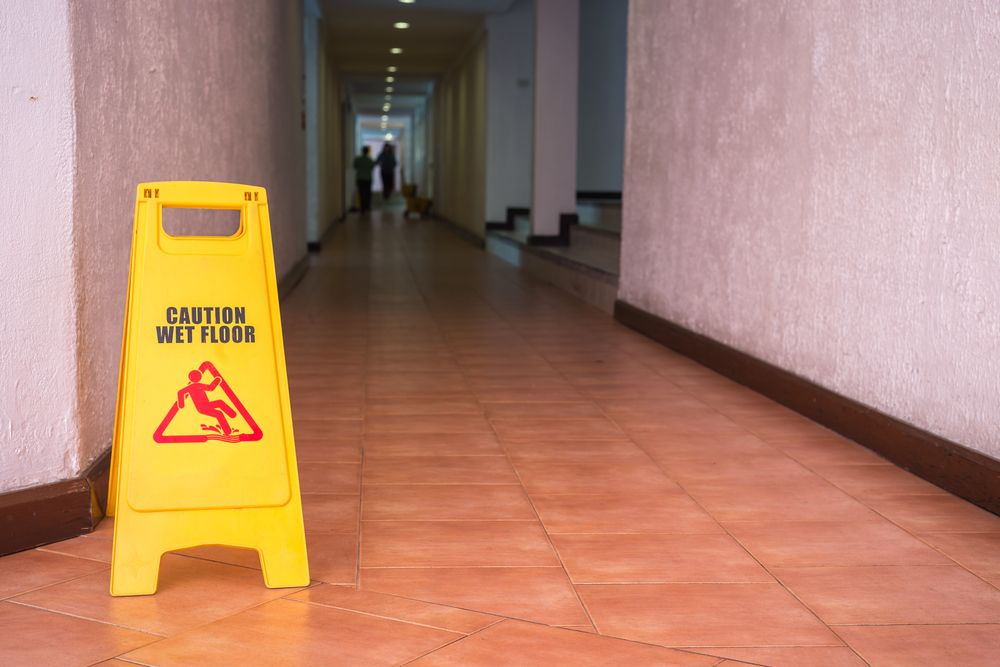What does the presence of a 'Caution Wet Floor' sign suggest about the building's policy on safety? The presence of a 'Caution Wet Floor' sign suggests that the building has a clear and proactive policy on safety. It indicates that the building management is attentive to potential hazards and takes necessary measures to mitigate risks promptly. This not only demonstrates a commitment to maintaining a safe environment for occupants and visitors but also reflects adherence to safety regulations and standards. Why is it important for buildings to have such safety policies in place? It's crucial for buildings to have safety policies in place to prevent accidents and ensure the well-being of everyone who uses the space. Effective safety measures, like the placement of caution signs, help to alert people to potential dangers, thereby reducing the risk of injuries. Moreover, maintaining a safe environment fosters trust and a sense of security among occupants and visitors. It also helps in complying with legal and regulatory requirements, which can prevent legal liabilities and protect the reputation of the building management. 